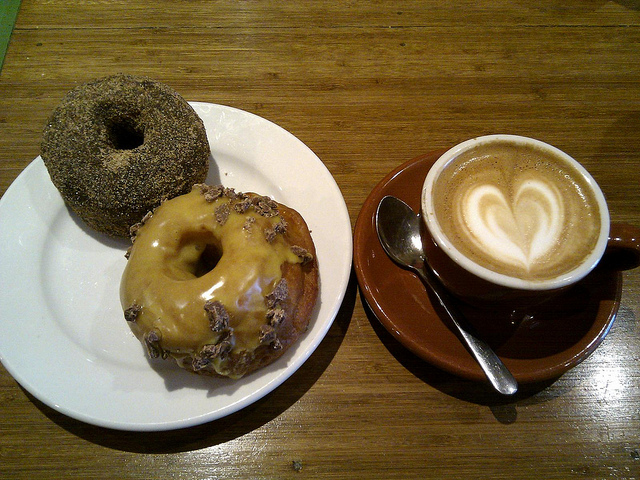Could you suggest what type of occasion or event could feature these items? This set-up could wonderfully suit a casual business meeting or a personal catch-up with a friend. The inviting look of the doughnuts paired with the cappuccino adds a relaxed yet sophisticated touch to the table, making it suitable for both professional and personal gatherings. 